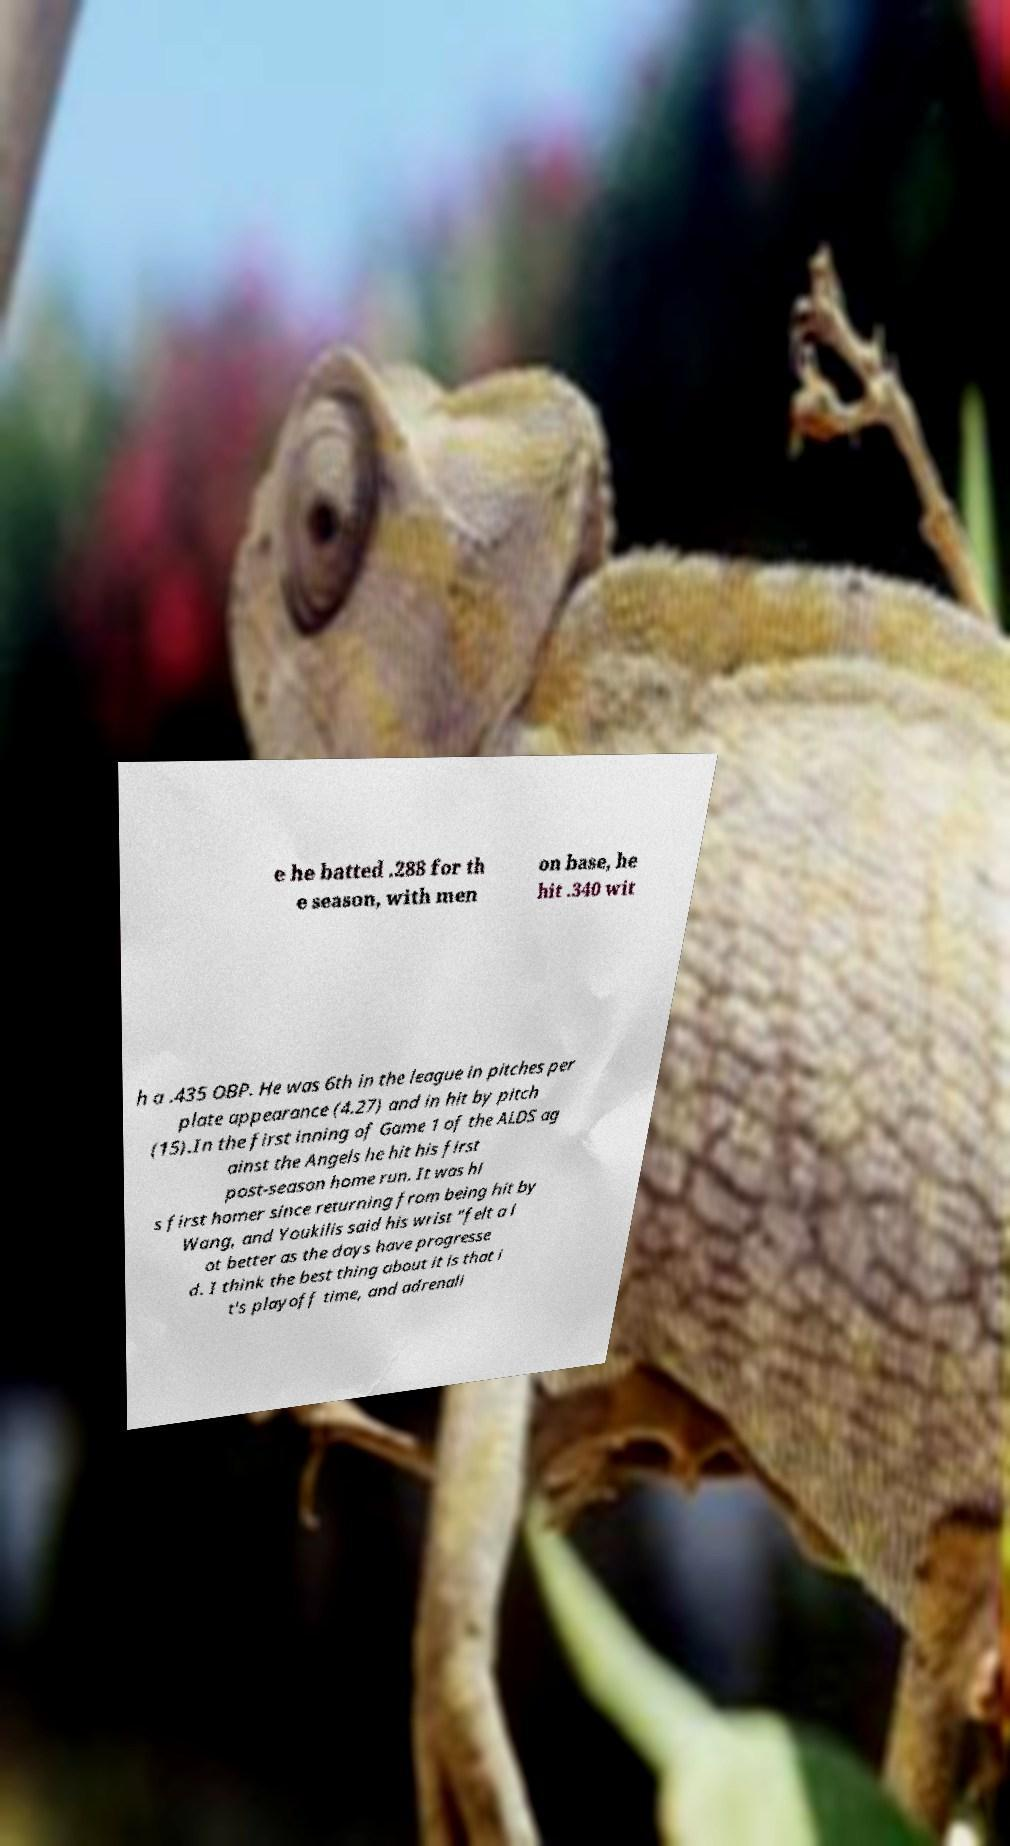Please read and relay the text visible in this image. What does it say? e he batted .288 for th e season, with men on base, he hit .340 wit h a .435 OBP. He was 6th in the league in pitches per plate appearance (4.27) and in hit by pitch (15).In the first inning of Game 1 of the ALDS ag ainst the Angels he hit his first post-season home run. It was hi s first homer since returning from being hit by Wang, and Youkilis said his wrist "felt a l ot better as the days have progresse d. I think the best thing about it is that i t's playoff time, and adrenali 